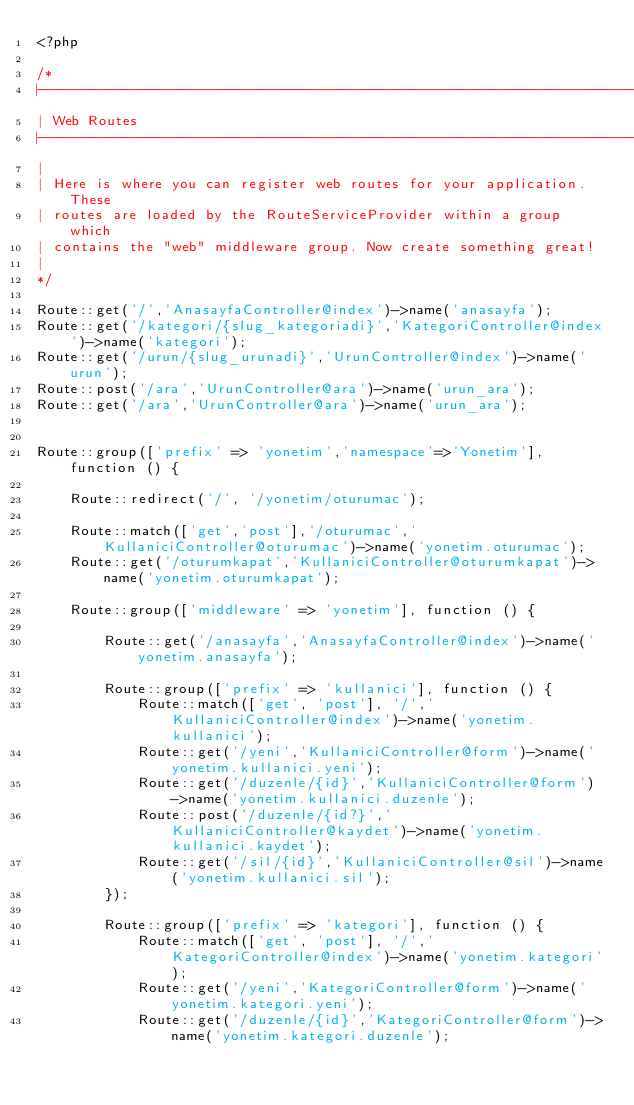Convert code to text. <code><loc_0><loc_0><loc_500><loc_500><_PHP_><?php

/*
|--------------------------------------------------------------------------
| Web Routes
|--------------------------------------------------------------------------
|
| Here is where you can register web routes for your application. These
| routes are loaded by the RouteServiceProvider within a group which
| contains the "web" middleware group. Now create something great!
|
*/

Route::get('/','AnasayfaController@index')->name('anasayfa');
Route::get('/kategori/{slug_kategoriadi}','KategoriController@index')->name('kategori');
Route::get('/urun/{slug_urunadi}','UrunController@index')->name('urun');
Route::post('/ara','UrunController@ara')->name('urun_ara');
Route::get('/ara','UrunController@ara')->name('urun_ara');


Route::group(['prefix' => 'yonetim','namespace'=>'Yonetim'], function () {

    Route::redirect('/', '/yonetim/oturumac');

    Route::match(['get','post'],'/oturumac','KullaniciController@oturumac')->name('yonetim.oturumac');
    Route::get('/oturumkapat','KullaniciController@oturumkapat')->name('yonetim.oturumkapat');

    Route::group(['middleware' => 'yonetim'], function () {

        Route::get('/anasayfa','AnasayfaController@index')->name('yonetim.anasayfa');

        Route::group(['prefix' => 'kullanici'], function () {
            Route::match(['get', 'post'], '/','KullaniciController@index')->name('yonetim.kullanici');
            Route::get('/yeni','KullaniciController@form')->name('yonetim.kullanici.yeni');
            Route::get('/duzenle/{id}','KullaniciController@form')->name('yonetim.kullanici.duzenle');
            Route::post('/duzenle/{id?}','KullaniciController@kaydet')->name('yonetim.kullanici.kaydet');
            Route::get('/sil/{id}','KullaniciController@sil')->name('yonetim.kullanici.sil');
        });

        Route::group(['prefix' => 'kategori'], function () {
            Route::match(['get', 'post'], '/','KategoriController@index')->name('yonetim.kategori');
            Route::get('/yeni','KategoriController@form')->name('yonetim.kategori.yeni');
            Route::get('/duzenle/{id}','KategoriController@form')->name('yonetim.kategori.duzenle');</code> 